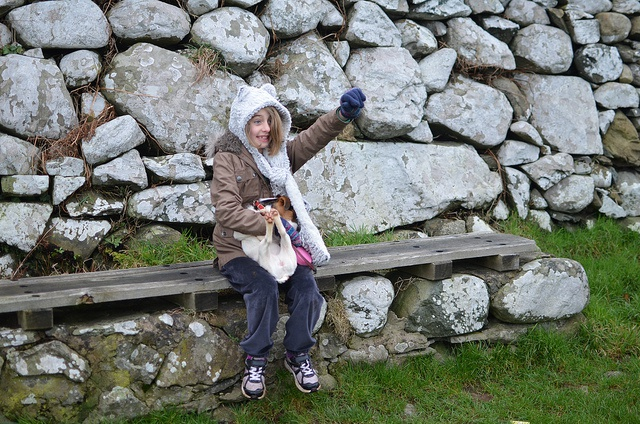Describe the objects in this image and their specific colors. I can see people in lightgray, gray, black, and darkgray tones, bench in lightgray, darkgray, gray, and black tones, handbag in lightgray, darkgray, and gray tones, and handbag in lightgray, lavender, darkgray, and gray tones in this image. 